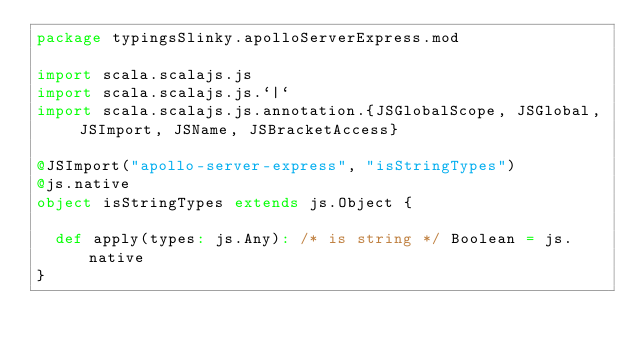<code> <loc_0><loc_0><loc_500><loc_500><_Scala_>package typingsSlinky.apolloServerExpress.mod

import scala.scalajs.js
import scala.scalajs.js.`|`
import scala.scalajs.js.annotation.{JSGlobalScope, JSGlobal, JSImport, JSName, JSBracketAccess}

@JSImport("apollo-server-express", "isStringTypes")
@js.native
object isStringTypes extends js.Object {
  
  def apply(types: js.Any): /* is string */ Boolean = js.native
}
</code> 